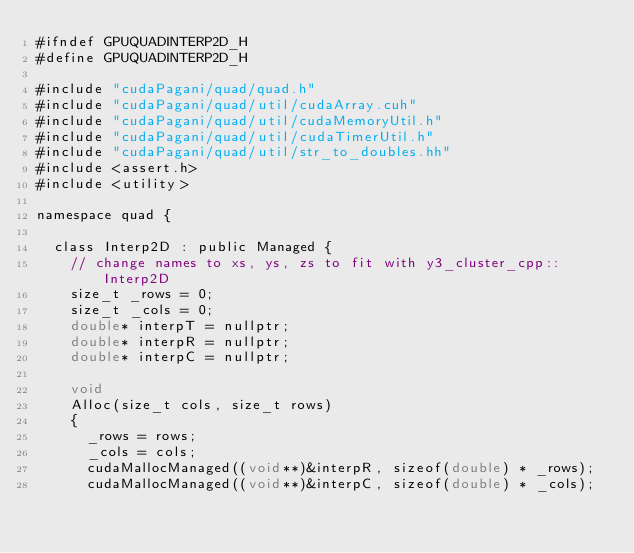<code> <loc_0><loc_0><loc_500><loc_500><_Cuda_>#ifndef GPUQUADINTERP2D_H
#define GPUQUADINTERP2D_H

#include "cudaPagani/quad/quad.h"
#include "cudaPagani/quad/util/cudaArray.cuh"
#include "cudaPagani/quad/util/cudaMemoryUtil.h"
#include "cudaPagani/quad/util/cudaTimerUtil.h"
#include "cudaPagani/quad/util/str_to_doubles.hh"
#include <assert.h>
#include <utility>

namespace quad {

  class Interp2D : public Managed {
    // change names to xs, ys, zs to fit with y3_cluster_cpp::Interp2D
    size_t _rows = 0;
    size_t _cols = 0;
    double* interpT = nullptr;
    double* interpR = nullptr;
    double* interpC = nullptr;

    void
    Alloc(size_t cols, size_t rows)
    {
      _rows = rows;
      _cols = cols;
      cudaMallocManaged((void**)&interpR, sizeof(double) * _rows);
      cudaMallocManaged((void**)&interpC, sizeof(double) * _cols);</code> 